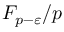Convert formula to latex. <formula><loc_0><loc_0><loc_500><loc_500>F _ { p - \varepsilon } / p</formula> 